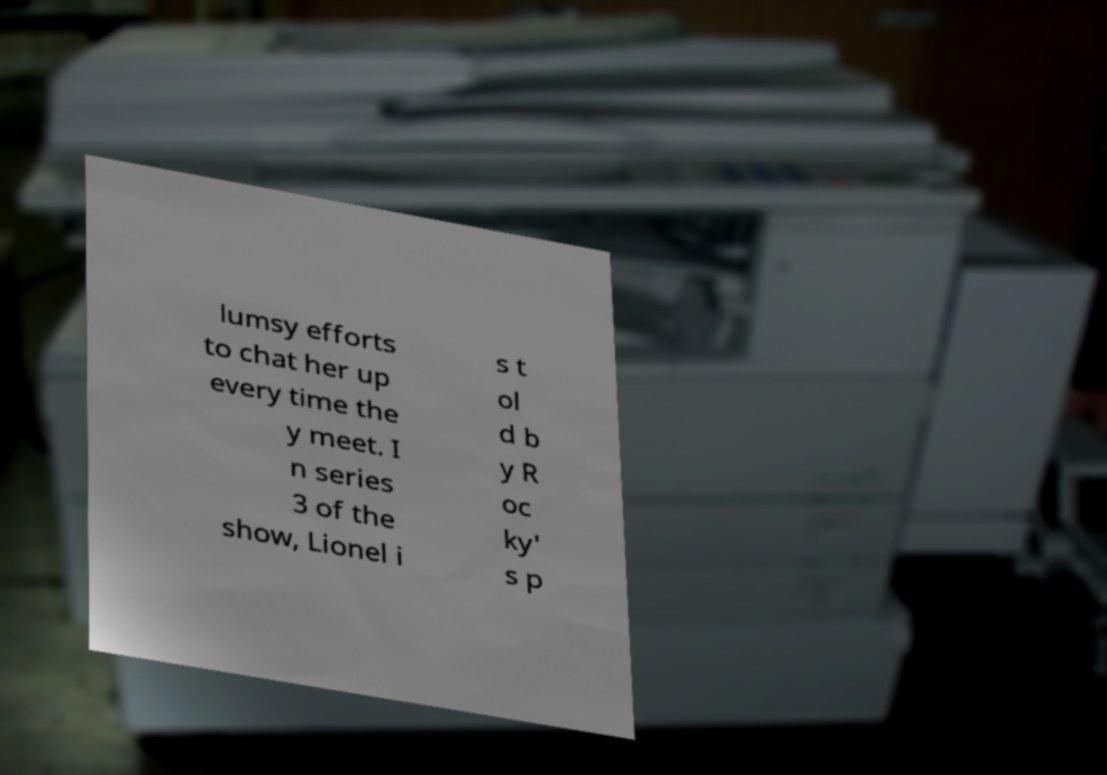For documentation purposes, I need the text within this image transcribed. Could you provide that? lumsy efforts to chat her up every time the y meet. I n series 3 of the show, Lionel i s t ol d b y R oc ky' s p 